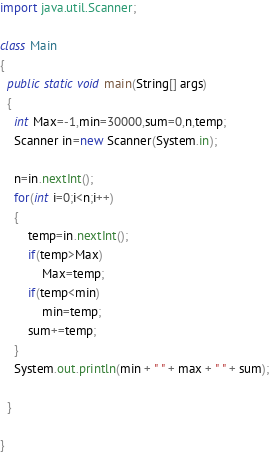<code> <loc_0><loc_0><loc_500><loc_500><_Java_>import java.util.Scanner;

class Main
{
  public static void main(String[] args)
  {
    int Max=-1,min=30000,sum=0,n,temp;
    Scanner in=new Scanner(System.in);
	
	n=in.nextInt();
	for(int i=0;i<n;i++)
	{
		temp=in.nextInt();
		if(temp>Max)
			Max=temp;
		if(temp<min)
			min=temp;
		sum+=temp;		
	}
	System.out.println(min + " " + max + " " + sum);
    
  }

}</code> 